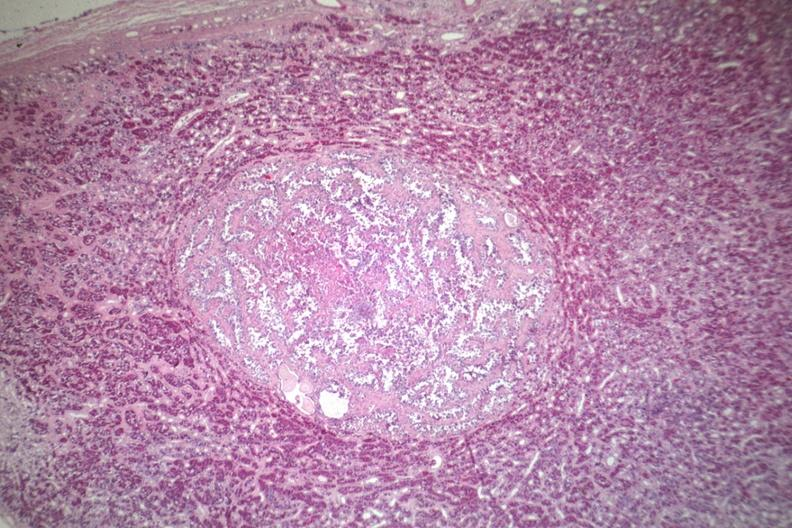what does this image show?
Answer the question using a single word or phrase. Well circumscribed papillary lesion see for high mag 